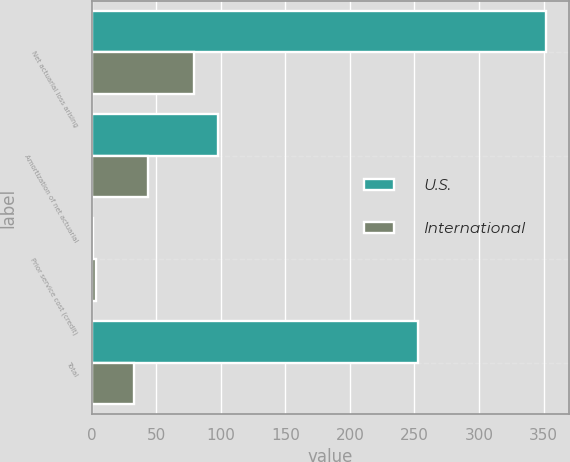Convert chart to OTSL. <chart><loc_0><loc_0><loc_500><loc_500><stacked_bar_chart><ecel><fcel>Net actuarial loss arising<fcel>Amortization of net actuarial<fcel>Prior service cost (credit)<fcel>Total<nl><fcel>U.S.<fcel>351.8<fcel>97.8<fcel>1.2<fcel>252.4<nl><fcel>International<fcel>79.4<fcel>43.3<fcel>3.1<fcel>33<nl></chart> 